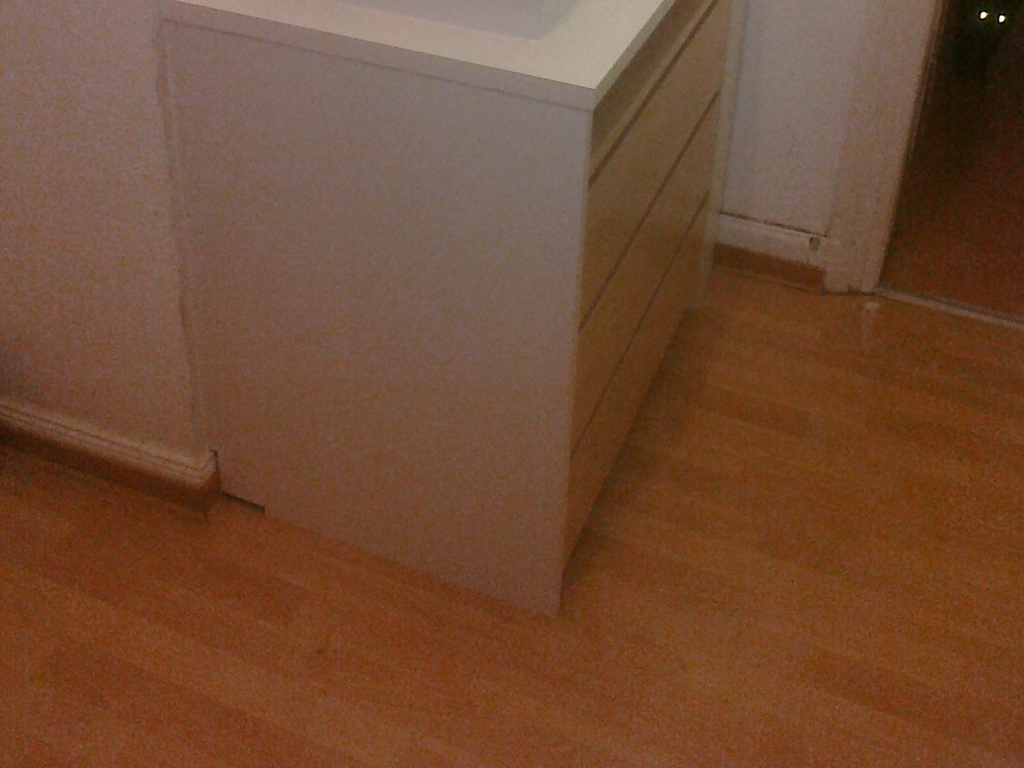Looking at the floor, what can you infer about the maintenance and condition of this interior space? The wooden floor presents a well-maintained appearance with a polished finish, suggestive of regular upkeep. The absence of visible scratches or damage indicates the space is cared for. However, there's a subtle contrast in the wood's tone near the cabinet's edge, perhaps signifying an area less exposed to foot traffic or sunlight, which might slightly shift the color over time. 